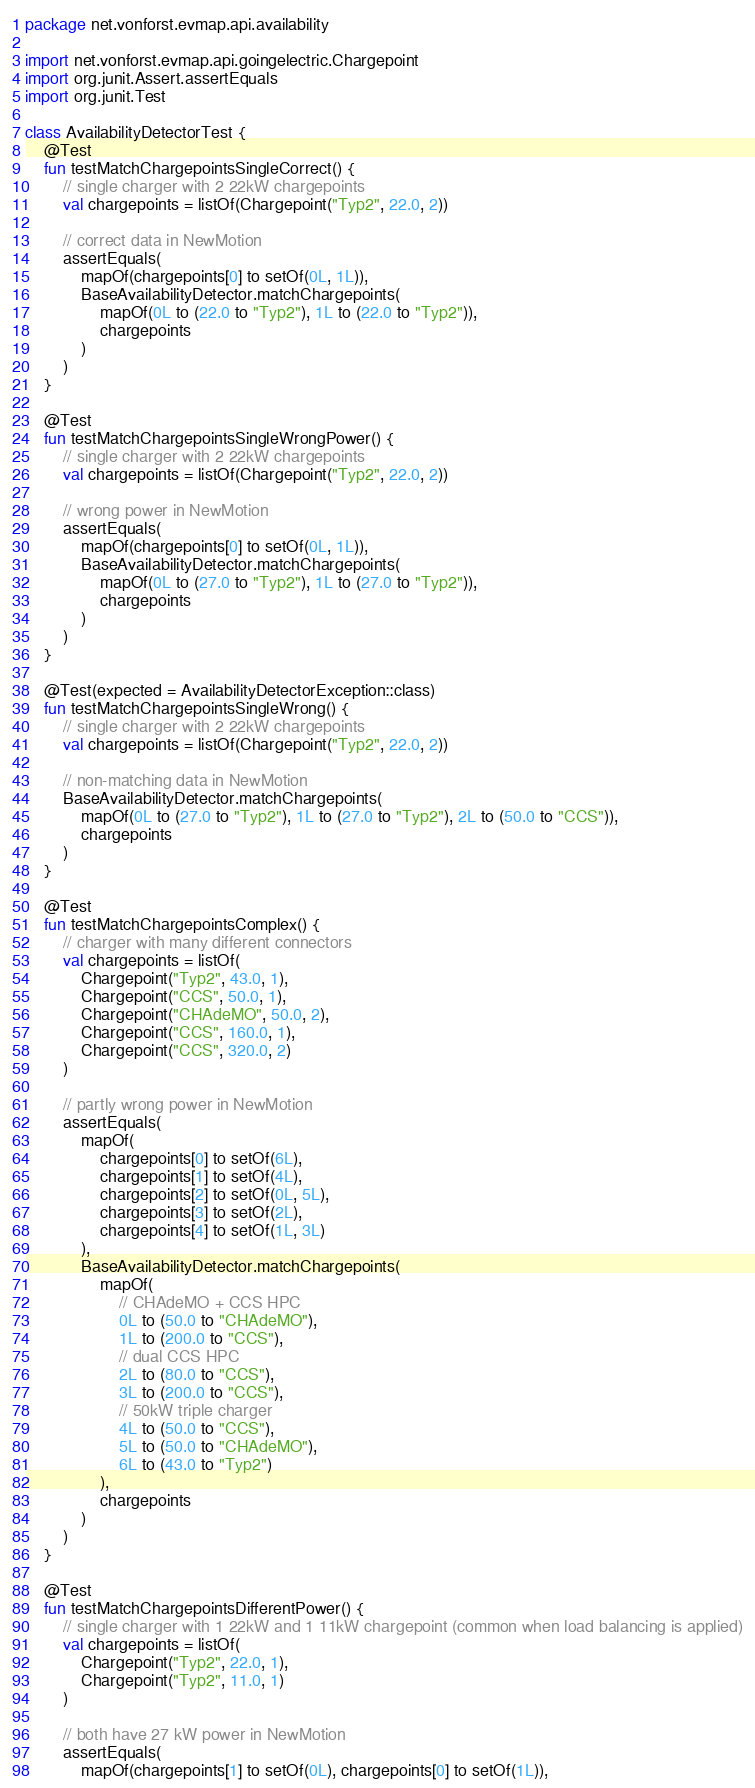Convert code to text. <code><loc_0><loc_0><loc_500><loc_500><_Kotlin_>package net.vonforst.evmap.api.availability

import net.vonforst.evmap.api.goingelectric.Chargepoint
import org.junit.Assert.assertEquals
import org.junit.Test

class AvailabilityDetectorTest {
    @Test
    fun testMatchChargepointsSingleCorrect() {
        // single charger with 2 22kW chargepoints
        val chargepoints = listOf(Chargepoint("Typ2", 22.0, 2))

        // correct data in NewMotion
        assertEquals(
            mapOf(chargepoints[0] to setOf(0L, 1L)),
            BaseAvailabilityDetector.matchChargepoints(
                mapOf(0L to (22.0 to "Typ2"), 1L to (22.0 to "Typ2")),
                chargepoints
            )
        )
    }

    @Test
    fun testMatchChargepointsSingleWrongPower() {
        // single charger with 2 22kW chargepoints
        val chargepoints = listOf(Chargepoint("Typ2", 22.0, 2))

        // wrong power in NewMotion
        assertEquals(
            mapOf(chargepoints[0] to setOf(0L, 1L)),
            BaseAvailabilityDetector.matchChargepoints(
                mapOf(0L to (27.0 to "Typ2"), 1L to (27.0 to "Typ2")),
                chargepoints
            )
        )
    }

    @Test(expected = AvailabilityDetectorException::class)
    fun testMatchChargepointsSingleWrong() {
        // single charger with 2 22kW chargepoints
        val chargepoints = listOf(Chargepoint("Typ2", 22.0, 2))

        // non-matching data in NewMotion
        BaseAvailabilityDetector.matchChargepoints(
            mapOf(0L to (27.0 to "Typ2"), 1L to (27.0 to "Typ2"), 2L to (50.0 to "CCS")),
            chargepoints
        )
    }

    @Test
    fun testMatchChargepointsComplex() {
        // charger with many different connectors
        val chargepoints = listOf(
            Chargepoint("Typ2", 43.0, 1),
            Chargepoint("CCS", 50.0, 1),
            Chargepoint("CHAdeMO", 50.0, 2),
            Chargepoint("CCS", 160.0, 1),
            Chargepoint("CCS", 320.0, 2)
        )

        // partly wrong power in NewMotion
        assertEquals(
            mapOf(
                chargepoints[0] to setOf(6L),
                chargepoints[1] to setOf(4L),
                chargepoints[2] to setOf(0L, 5L),
                chargepoints[3] to setOf(2L),
                chargepoints[4] to setOf(1L, 3L)
            ),
            BaseAvailabilityDetector.matchChargepoints(
                mapOf(
                    // CHAdeMO + CCS HPC
                    0L to (50.0 to "CHAdeMO"),
                    1L to (200.0 to "CCS"),
                    // dual CCS HPC
                    2L to (80.0 to "CCS"),
                    3L to (200.0 to "CCS"),
                    // 50kW triple charger
                    4L to (50.0 to "CCS"),
                    5L to (50.0 to "CHAdeMO"),
                    6L to (43.0 to "Typ2")
                ),
                chargepoints
            )
        )
    }

    @Test
    fun testMatchChargepointsDifferentPower() {
        // single charger with 1 22kW and 1 11kW chargepoint (common when load balancing is applied)
        val chargepoints = listOf(
            Chargepoint("Typ2", 22.0, 1),
            Chargepoint("Typ2", 11.0, 1)
        )

        // both have 27 kW power in NewMotion
        assertEquals(
            mapOf(chargepoints[1] to setOf(0L), chargepoints[0] to setOf(1L)),</code> 